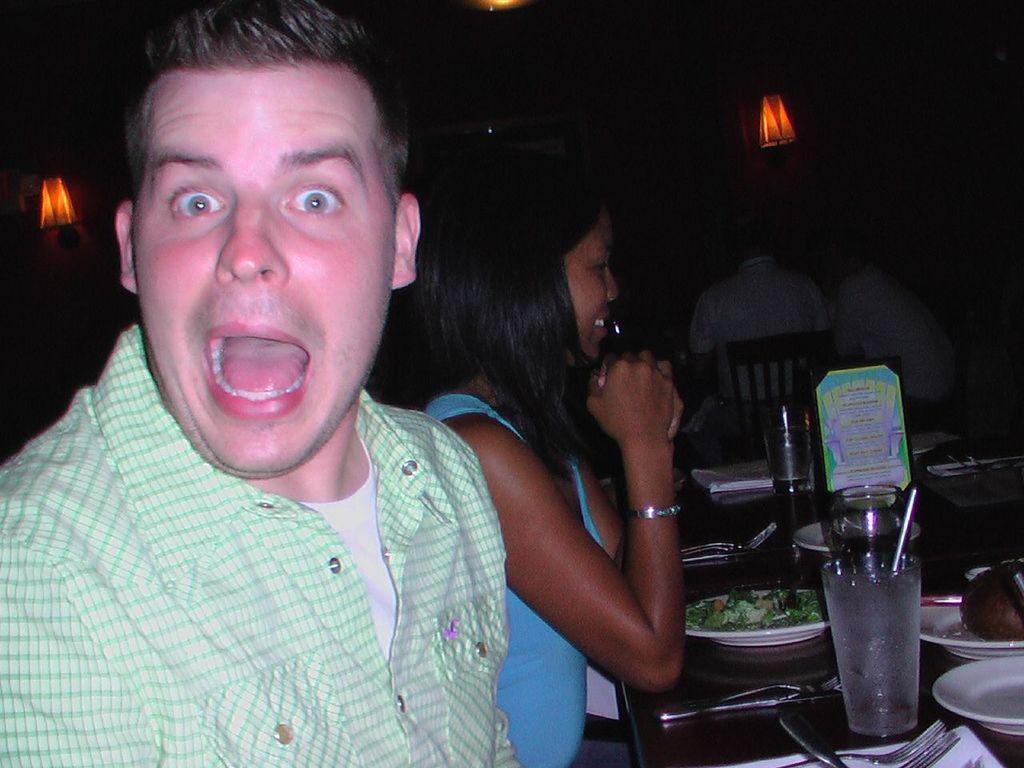Please provide a concise description of this image. In this picture there are group of people sitting on the chairs. There are glasses, plates, tissues, forks and there is a board on the table. At the back there are lights on the wall. At the top there is a light. 